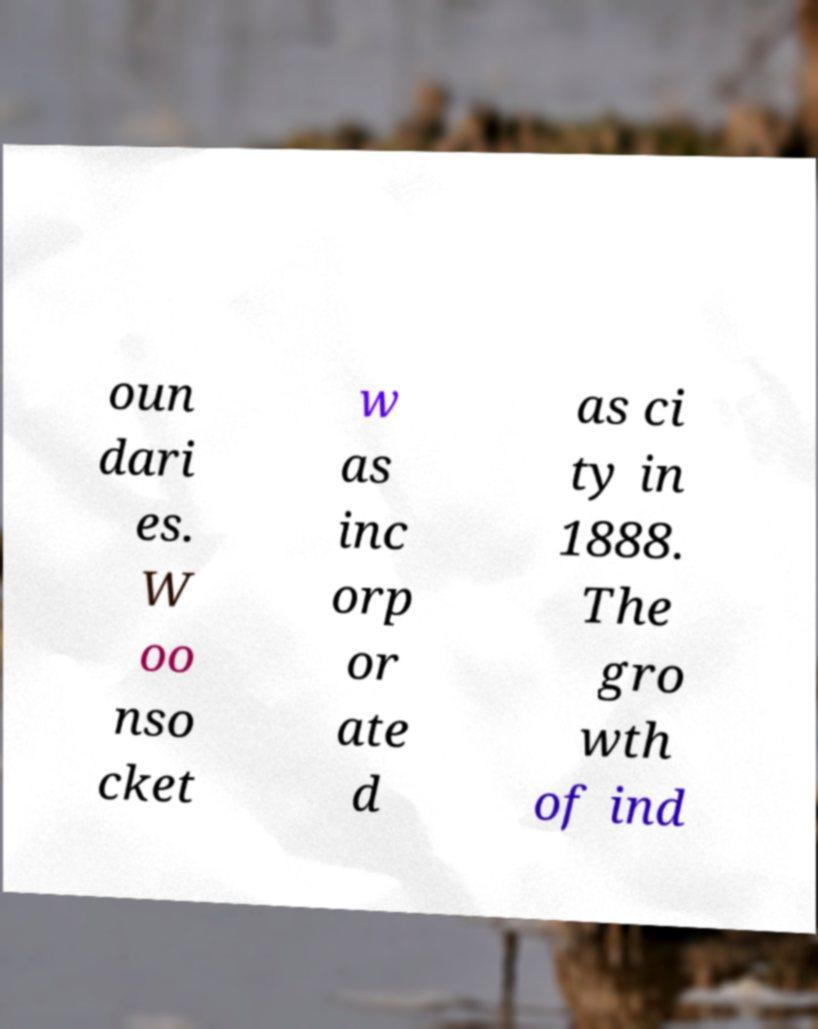Could you assist in decoding the text presented in this image and type it out clearly? oun dari es. W oo nso cket w as inc orp or ate d as ci ty in 1888. The gro wth of ind 